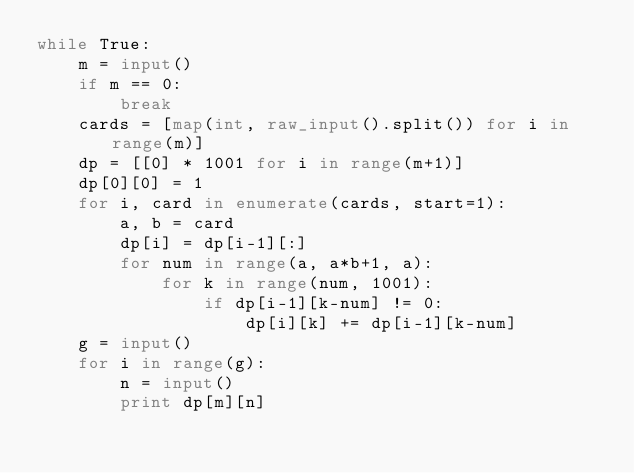Convert code to text. <code><loc_0><loc_0><loc_500><loc_500><_Python_>while True:
    m = input()
    if m == 0:
        break
    cards = [map(int, raw_input().split()) for i in range(m)]
    dp = [[0] * 1001 for i in range(m+1)]
    dp[0][0] = 1
    for i, card in enumerate(cards, start=1):
        a, b = card
        dp[i] = dp[i-1][:]
        for num in range(a, a*b+1, a):
            for k in range(num, 1001):
                if dp[i-1][k-num] != 0:
                    dp[i][k] += dp[i-1][k-num]
    g = input()
    for i in range(g):
        n = input()
        print dp[m][n]</code> 